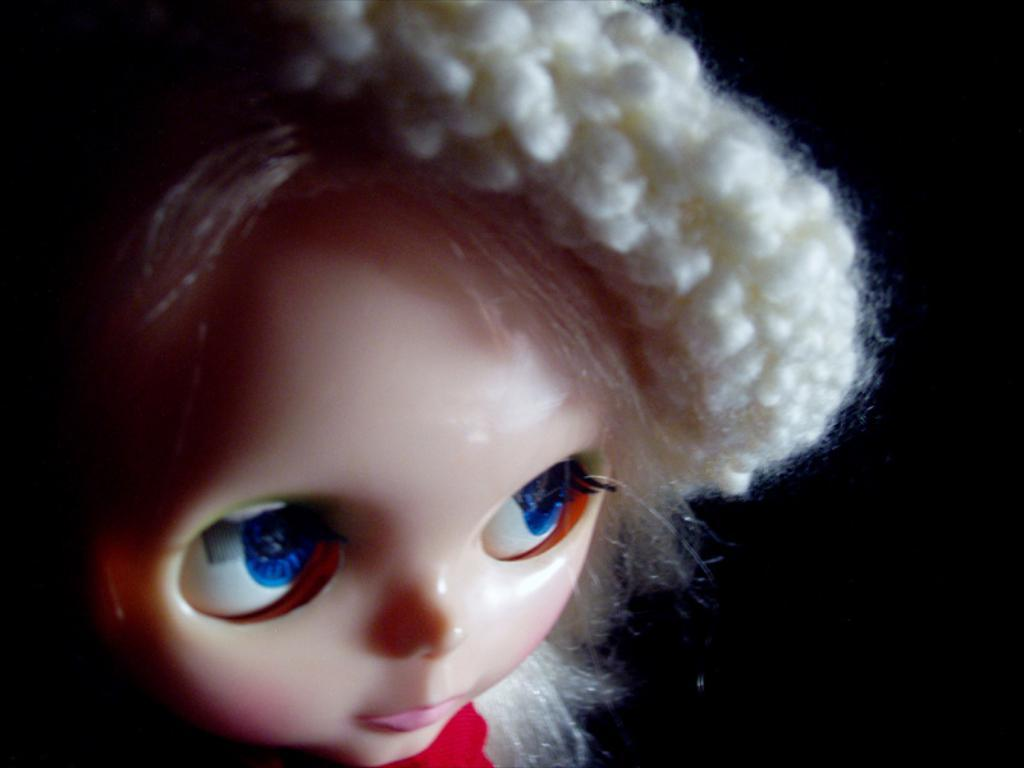What is the main subject of the image? There is a doll in the image. Can you describe the background of the image? The background of the image is dark. What type of glove is the creature wearing in the image? There is no creature or glove present in the image; it only features a doll. 